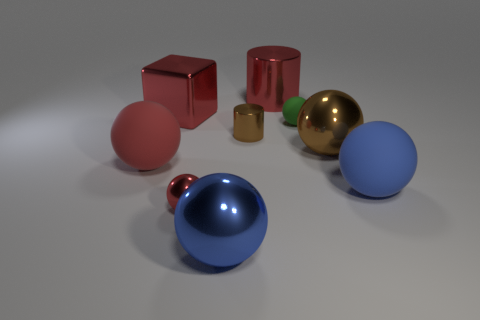Subtract all tiny spheres. How many spheres are left? 4 Add 1 red cylinders. How many objects exist? 10 Subtract all cubes. How many objects are left? 8 Subtract all brown spheres. How many spheres are left? 5 Subtract 2 balls. How many balls are left? 4 Subtract all big green rubber blocks. Subtract all tiny green matte spheres. How many objects are left? 8 Add 9 red metallic cylinders. How many red metallic cylinders are left? 10 Add 1 large red metallic balls. How many large red metallic balls exist? 1 Subtract 1 red blocks. How many objects are left? 8 Subtract all yellow balls. Subtract all gray cubes. How many balls are left? 6 